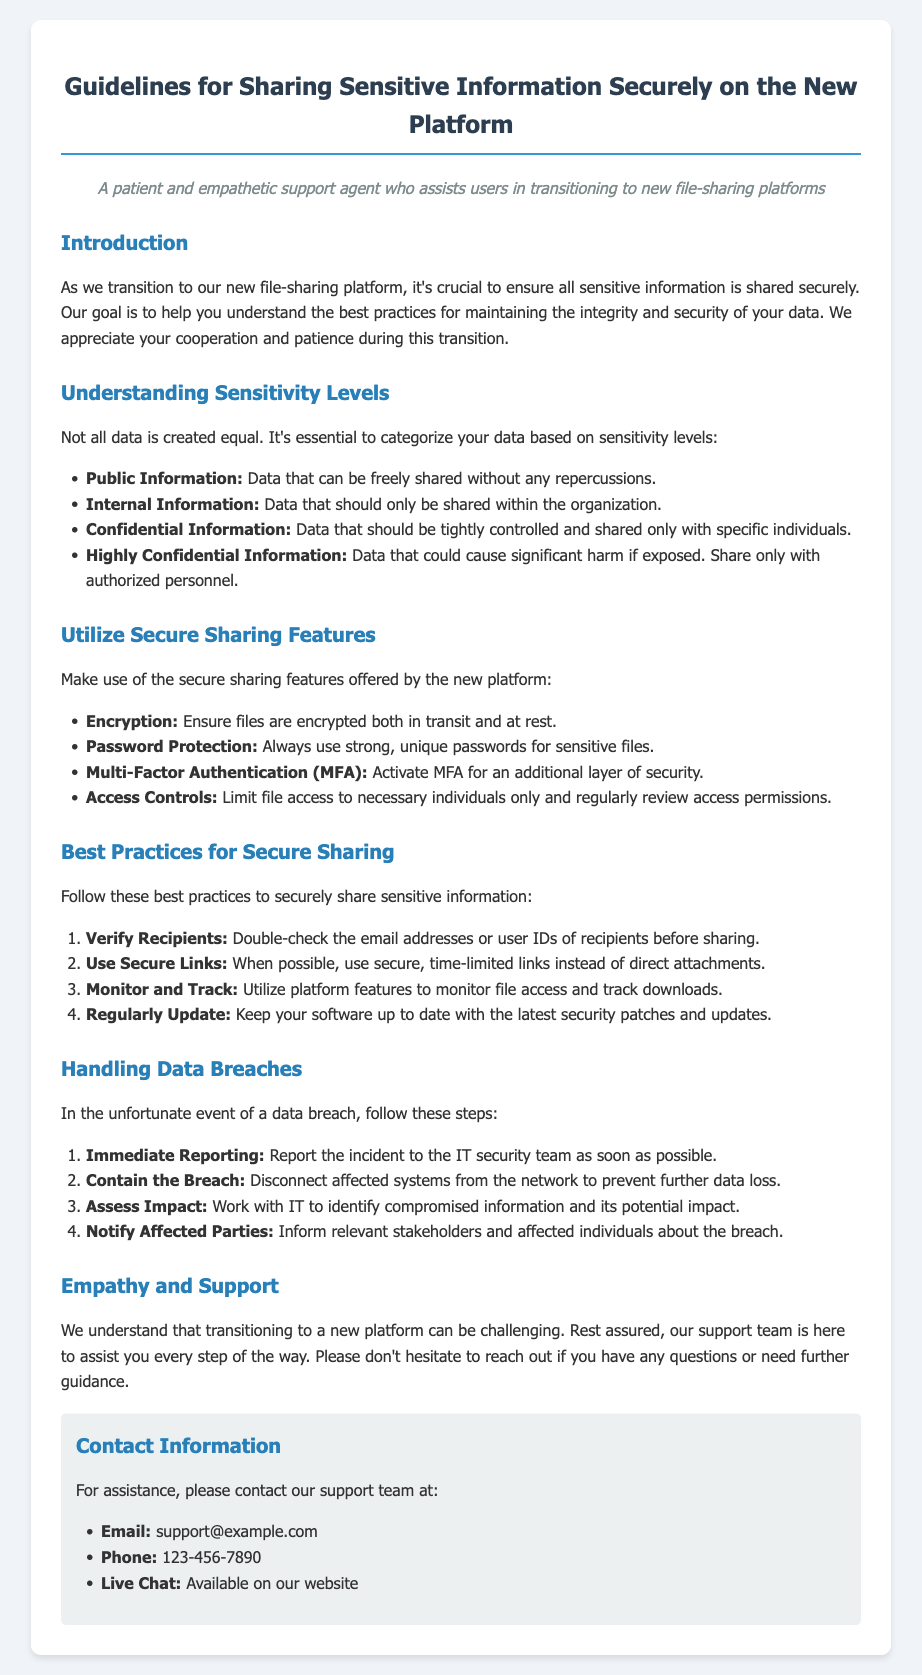What are the four sensitivity levels of data? The document lists four sensitivity levels, categorized as Public Information, Internal Information, Confidential Information, and Highly Confidential Information.
Answer: Public Information, Internal Information, Confidential Information, Highly Confidential Information What is one secure feature to use when sharing files? The document mentions several secure features; one example is Encryption, which ensures files are encrypted both in transit and at rest.
Answer: Encryption How many best practices for secure sharing are listed in the document? The document outlines four best practices for securely sharing sensitive information.
Answer: Four Who should be notified in the event of a data breach? The document states that relevant stakeholders and affected individuals should be informed about the breach.
Answer: Relevant stakeholders and affected individuals What is the contact email for support? The contact information section specifies the email for assistance is support@example.com.
Answer: support@example.com 